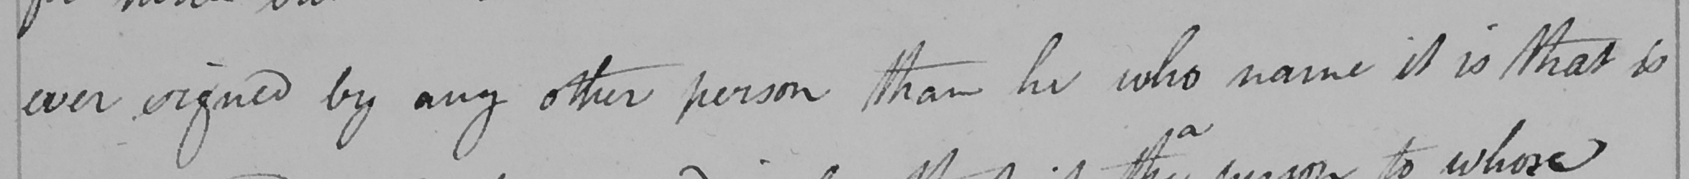Please transcribe the handwritten text in this image. ever signed by any other person than he who name it is that is 